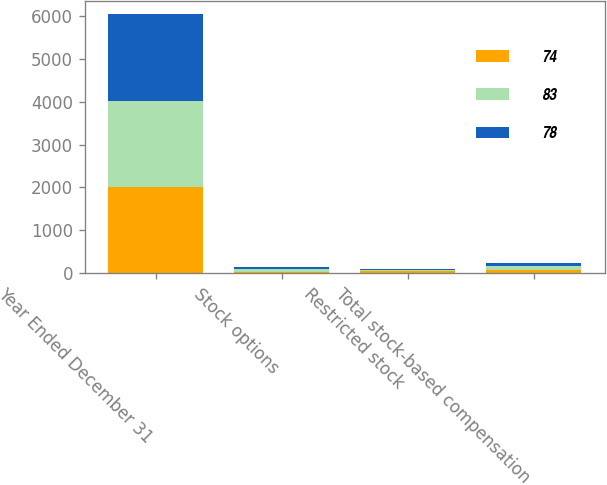<chart> <loc_0><loc_0><loc_500><loc_500><stacked_bar_chart><ecel><fcel>Year Ended December 31<fcel>Stock options<fcel>Restricted stock<fcel>Total stock-based compensation<nl><fcel>74<fcel>2014<fcel>38<fcel>45<fcel>83<nl><fcel>83<fcel>2013<fcel>48<fcel>30<fcel>78<nl><fcel>78<fcel>2012<fcel>57<fcel>17<fcel>74<nl></chart> 